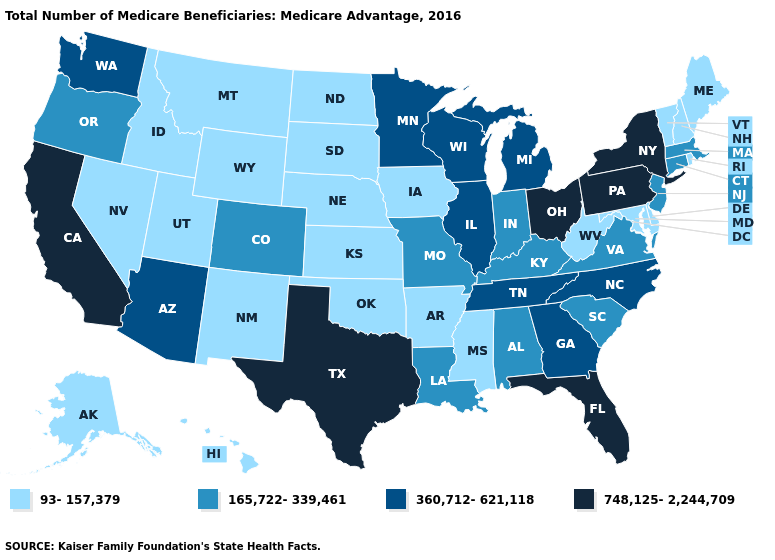Does Pennsylvania have the lowest value in the Northeast?
Keep it brief. No. Does South Carolina have the lowest value in the USA?
Write a very short answer. No. Name the states that have a value in the range 748,125-2,244,709?
Quick response, please. California, Florida, New York, Ohio, Pennsylvania, Texas. Which states hav the highest value in the Northeast?
Concise answer only. New York, Pennsylvania. What is the value of Idaho?
Give a very brief answer. 93-157,379. Which states hav the highest value in the Northeast?
Write a very short answer. New York, Pennsylvania. Does the first symbol in the legend represent the smallest category?
Keep it brief. Yes. What is the value of Arizona?
Answer briefly. 360,712-621,118. What is the value of Idaho?
Concise answer only. 93-157,379. Among the states that border New Hampshire , does Vermont have the lowest value?
Give a very brief answer. Yes. Which states have the lowest value in the Northeast?
Answer briefly. Maine, New Hampshire, Rhode Island, Vermont. Does Kentucky have the lowest value in the South?
Concise answer only. No. What is the lowest value in states that border Tennessee?
Concise answer only. 93-157,379. What is the highest value in the MidWest ?
Concise answer only. 748,125-2,244,709. Among the states that border Kansas , which have the lowest value?
Give a very brief answer. Nebraska, Oklahoma. 